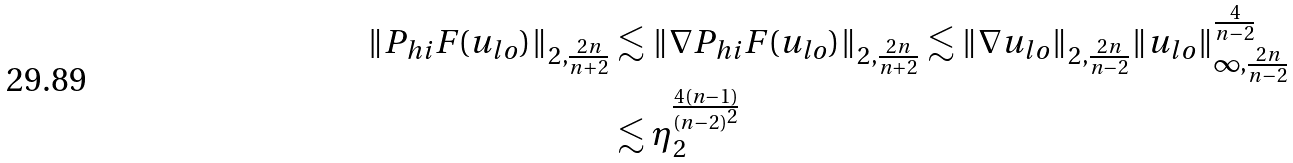Convert formula to latex. <formula><loc_0><loc_0><loc_500><loc_500>\| P _ { h i } F ( u _ { l o } ) \| _ { 2 , \frac { 2 n } { n + 2 } } & \lesssim \| \nabla P _ { h i } F ( u _ { l o } ) \| _ { 2 , \frac { 2 n } { n + 2 } } \lesssim \| \nabla u _ { l o } \| _ { 2 , \frac { 2 n } { n - 2 } } \| u _ { l o } \| _ { \infty , \frac { 2 n } { n - 2 } } ^ { \frac { 4 } { n - 2 } } \\ & \lesssim \eta _ { 2 } ^ { \frac { 4 ( n - 1 ) } { ( n - 2 ) ^ { 2 } } }</formula> 